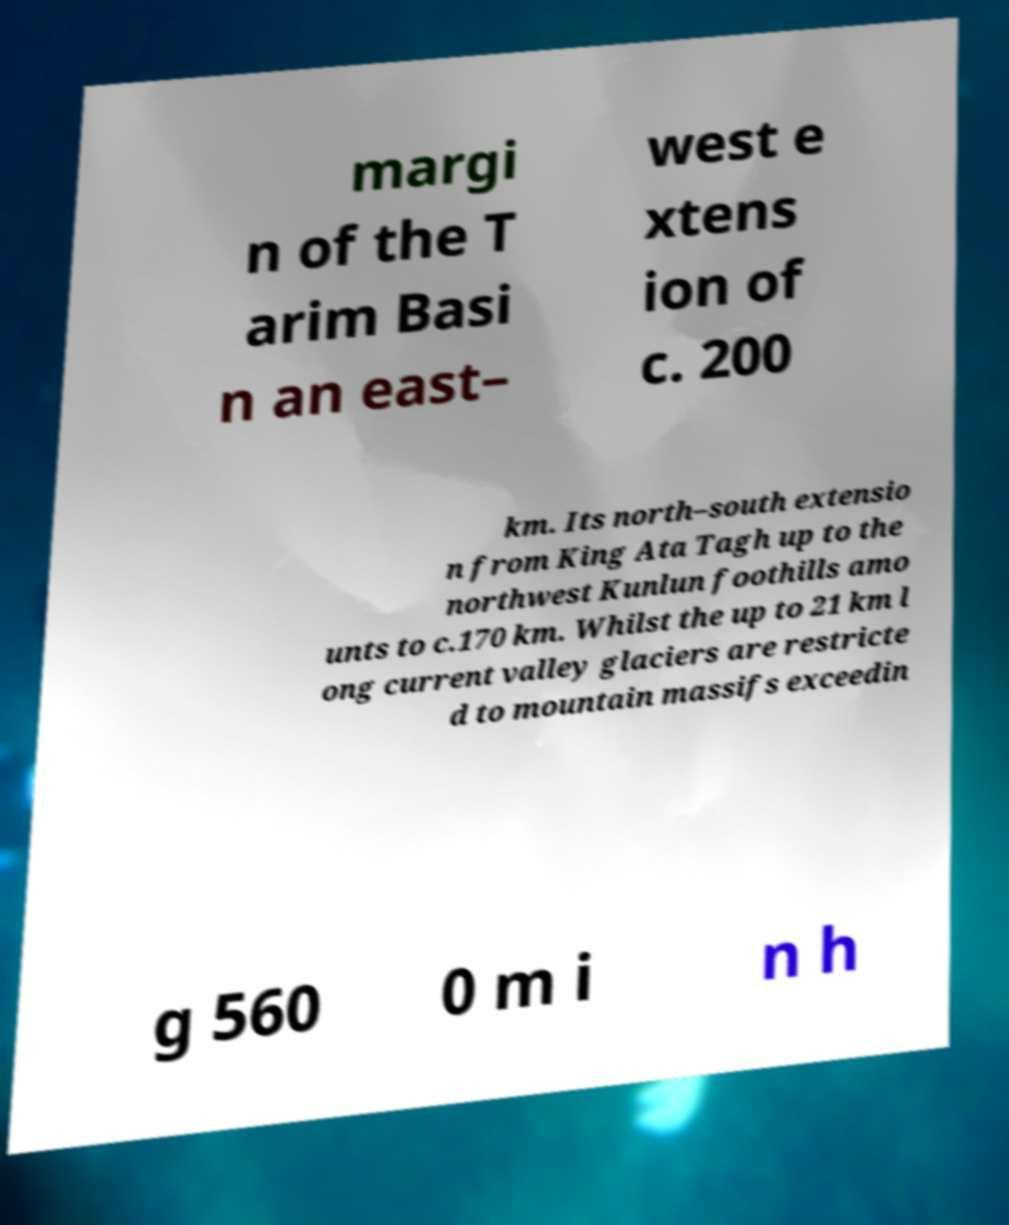What messages or text are displayed in this image? I need them in a readable, typed format. margi n of the T arim Basi n an east– west e xtens ion of c. 200 km. Its north–south extensio n from King Ata Tagh up to the northwest Kunlun foothills amo unts to c.170 km. Whilst the up to 21 km l ong current valley glaciers are restricte d to mountain massifs exceedin g 560 0 m i n h 